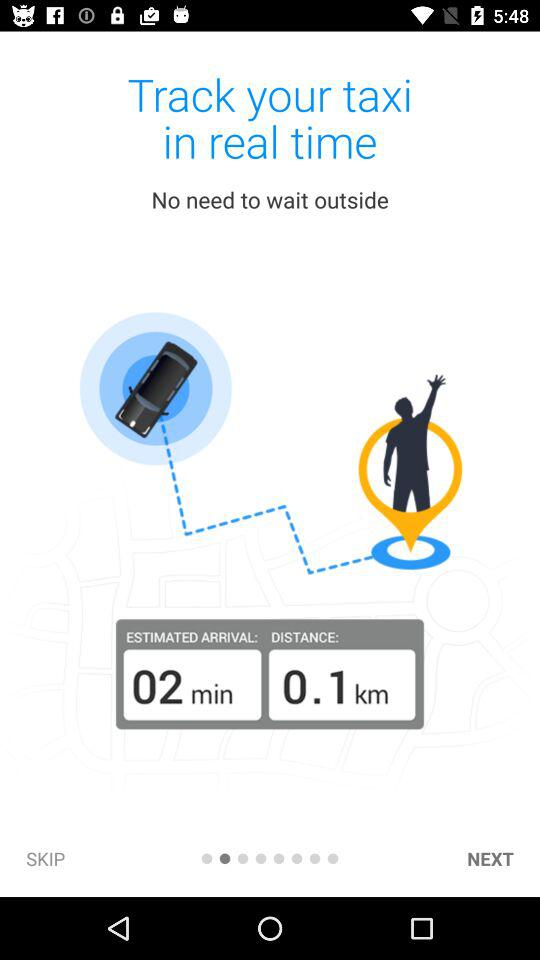What is the distance? The distance is 0.1 km. 